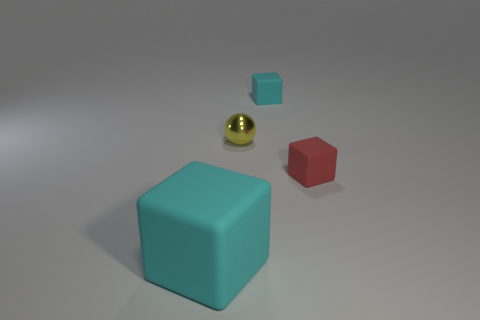There is a cube that is behind the small metallic object; is it the same color as the small object in front of the tiny metallic object?
Ensure brevity in your answer.  No. There is a shiny ball that is the same size as the red object; what is its color?
Keep it short and to the point. Yellow. Are there the same number of metallic balls left of the small shiny object and cyan rubber objects in front of the small cyan thing?
Your answer should be very brief. No. What is the material of the cube that is right of the small rubber thing that is behind the ball?
Provide a succinct answer. Rubber. How many objects are either big brown blocks or tiny things?
Ensure brevity in your answer.  3. The other rubber thing that is the same color as the large object is what size?
Provide a succinct answer. Small. Is the number of tiny red objects less than the number of small matte things?
Your answer should be very brief. Yes. What is the size of the other cyan thing that is the same material as the tiny cyan object?
Offer a very short reply. Large. There is a red object; what shape is it?
Make the answer very short. Cube. There is a rubber thing that is behind the yellow metal object; does it have the same color as the large matte object?
Make the answer very short. Yes. 